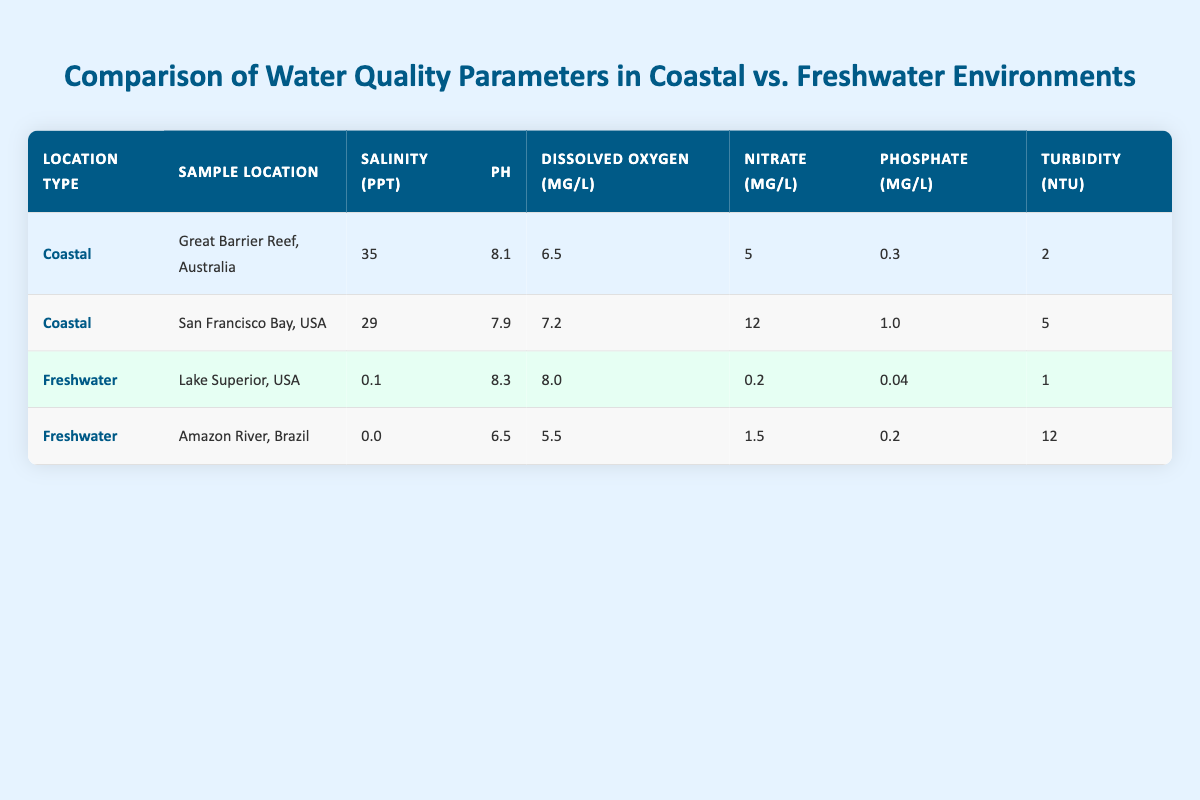What is the salinity of the Great Barrier Reef? The table shows that for the Great Barrier Reef, the salinity is recorded as 35 ppt.
Answer: 35 ppt What is the average pH of freshwater samples? The pH levels for the freshwater samples are 8.3 (Lake Superior) and 6.5 (Amazon River). The average is (8.3 + 6.5) / 2 = 7.4.
Answer: 7.4 Which location has the highest nutrient levels for nitrate? Looking at the table, San Francisco Bay has the highest nitrate levels recorded at 12 µg/L, compared to 5 µg/L in Great Barrier Reef, 0.2 µg/L in Lake Superior, and 1.5 µg/L in Amazon River.
Answer: San Francisco Bay Is the dissolved oxygen in Lake Superior higher than in other locations? Lake Superior has a dissolved oxygen level of 8.0 mg/L, which is higher than Amazon River (5.5 mg/L) but lower than San Francisco Bay (7.2 mg/L) and Great Barrier Reef (6.5 mg/L).
Answer: No What is the turbidity difference between the Amazon River and Great Barrier Reef? The turbidity in the Amazon River is 12 NTU and in Great Barrier Reef is 2 NTU. The difference is 12 - 2 = 10 NTU.
Answer: 10 NTU Which water type has a higher average phosphate level? The phosphate levels for coastal locations (0.3 + 1.0) / 2 = 0.65 µg/L and for freshwater (0.04 + 0.2) / 2 = 0.12 µg/L show that coastal waters have a higher average phosphate level.
Answer: Coastal Is the dissolved oxygen level in freshwater samples consistently higher than in coastal samples? For freshwater, Lake Superior has 8.0 mg/L and Amazon River has 5.5 mg/L, averaging 6.75 mg/L, while coastal waters average (6.5 + 7.2) / 2 = 6.85 mg/L. This shows that coastal samples are slightly higher.
Answer: No What is the highest pH level recorded in any of the samples? Among all the samples, Lake Superior has the highest pH level at 8.3, compared to 8.1 in Great Barrier Reef, 7.9 in San Francisco Bay, and 6.5 in Amazon River.
Answer: 8.3 What is the average salinity of coastal samples? The salinity levels for coastal samples are 35 ppt (Great Barrier Reef) and 29 ppt (San Francisco Bay). The average calculation is (35 + 29) / 2 = 32 ppt.
Answer: 32 ppt 